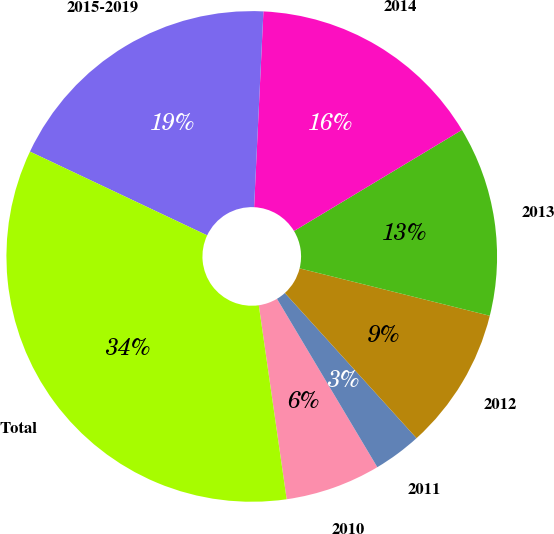<chart> <loc_0><loc_0><loc_500><loc_500><pie_chart><fcel>2010<fcel>2011<fcel>2012<fcel>2013<fcel>2014<fcel>2015-2019<fcel>Total<nl><fcel>6.28%<fcel>3.17%<fcel>9.39%<fcel>12.51%<fcel>15.62%<fcel>18.73%<fcel>34.3%<nl></chart> 